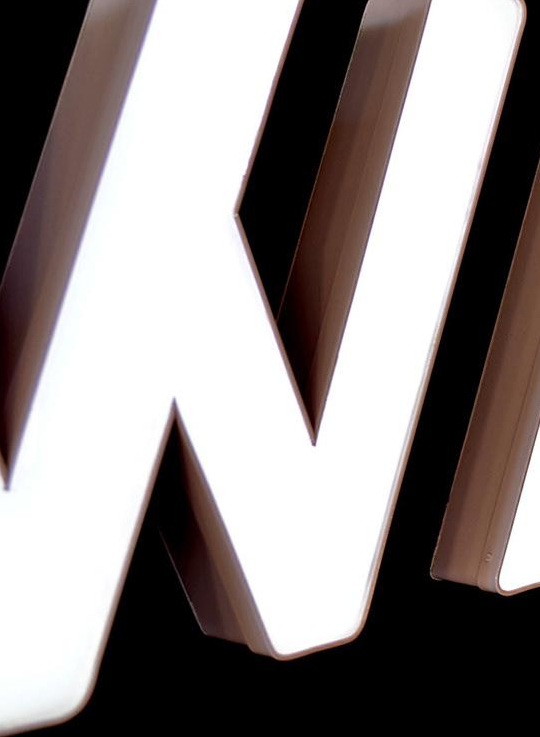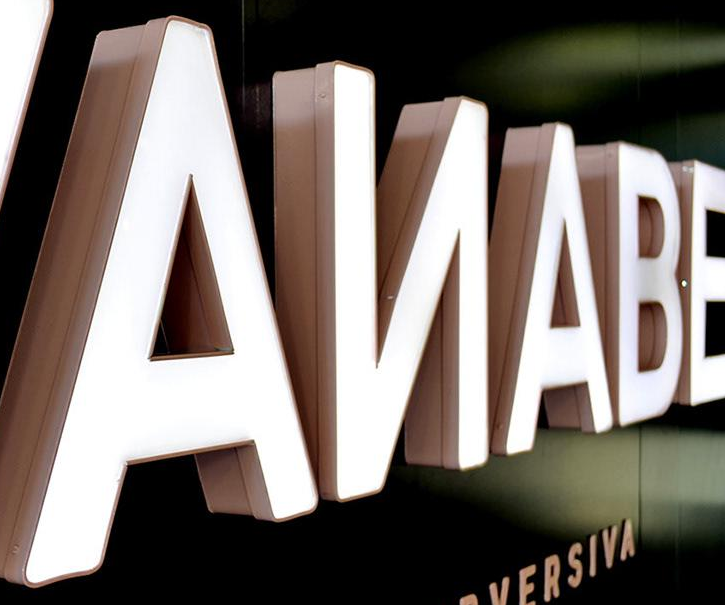Transcribe the words shown in these images in order, separated by a semicolon. #; AИABE 